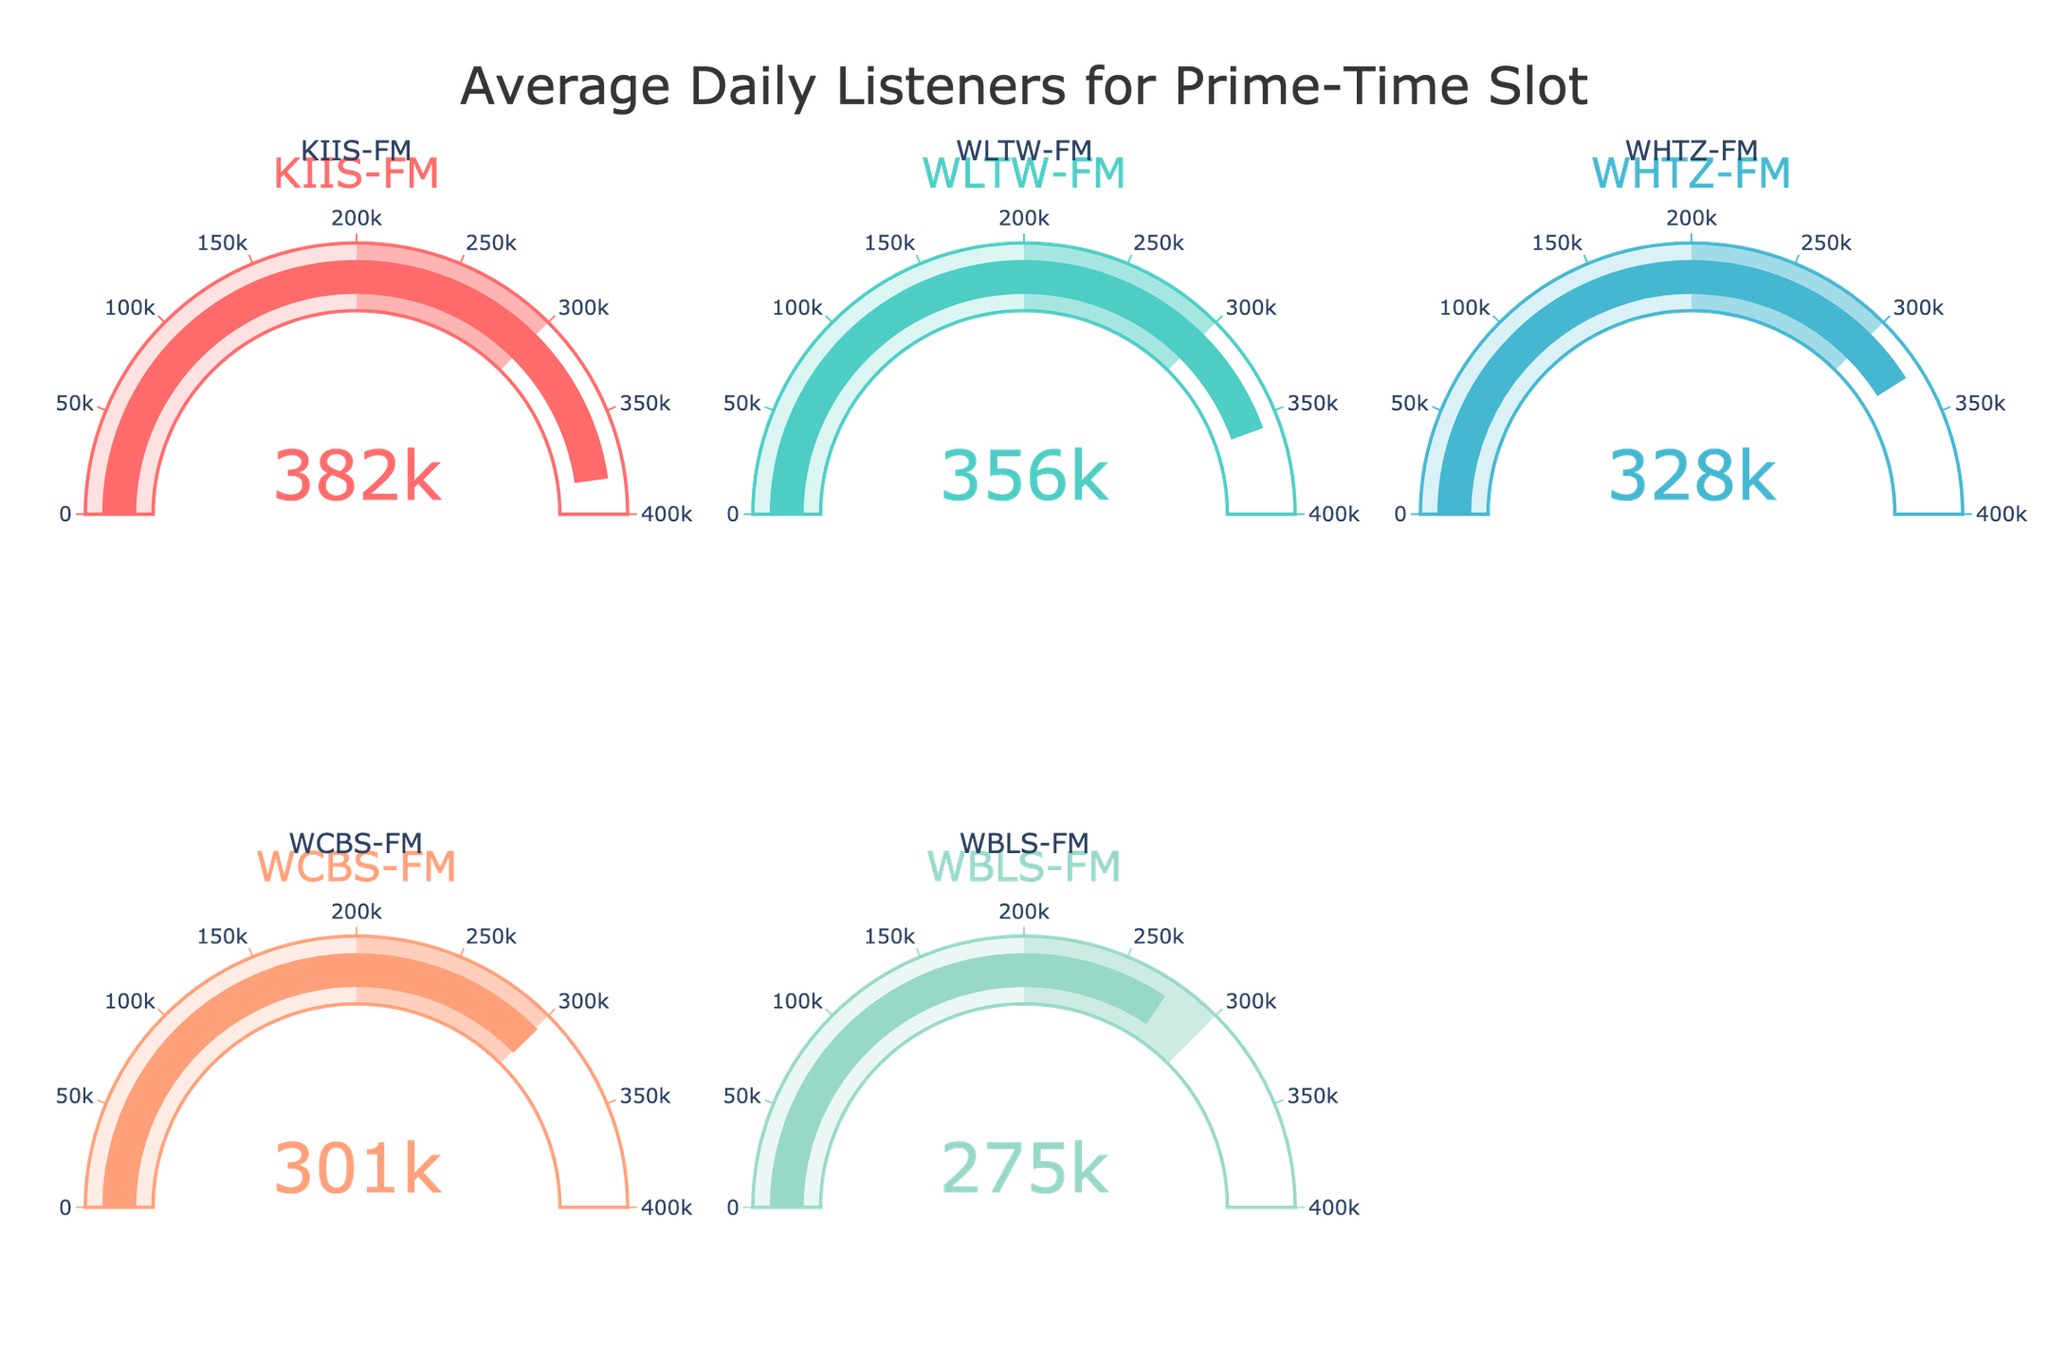1. What is the title of the figure? The title of the figure is displayed at the top and reads "Average Daily Listeners for Prime-Time Slot".
Answer: Average Daily Listeners for Prime-Time Slot 2. Which station has the highest average daily listeners for the prime-time slot? The station with the pointer closest to the maximum value on its gauge is KIIS-FM, indicating it has the highest average daily listeners.
Answer: KIIS-FM 3. How many stations have their average daily listeners displayed in the figure? The figure contains five gauges, each labeled with a different station, indicating there are five stations.
Answer: 5 4. What is the average daily listeners count for WHTZ-FM? By reading the value pointer on the gauge labeled WHTZ-FM, we can see it points to 328,000.
Answer: 328,000 5. Which station has fewer average daily listeners: WCBS-FM or WLTW-FM? Compare the gauge values of both stations. WCBS-FM has 301,000 average daily listeners while WLTW-FM has 356,000. WCBS-FM has fewer listeners.
Answer: WCBS-FM 6. What is the combined average daily listeners count for WBLS-FM and WHTZ-FM? Sum the values for WBLS-FM and WHTZ-FM. WBLS-FM has 275,000 listeners and WHTZ-FM has 328,000 listeners. So, 275,000 + 328,000 = 603,000.
Answer: 603,000 7. What is the range of the gauges for the average daily listeners? The scale on all gauges ranges from 0 to 400,000 as indicated on the axis.
Answer: 0 to 400,000 8. By how much does the average daily listeners count of WHTZ-FM exceed WBLS-FM? Subtract the value of WBLS-FM from the value of WHTZ-FM: 328,000 - 275,000 = 53,000.
Answer: 53,000 9. Which station has the darkest gauge color? The gauge colors represent intensity, with darker colors indicating higher values within preset ranges. KIIS-FM has the darkest gauge color due to having the highest value.
Answer: KIIS-FM 10. If you average the daily listeners of the three stations with the lowest listeners, what is the result? Average the values for WCBS-FM (301,000), WBLS-FM (275,000), and WHTZ-FM (328,000): (301,000 + 275,000 + 328,000) / 3 = 904,000 / 3 ≈ 301,333.
Answer: 301,333 